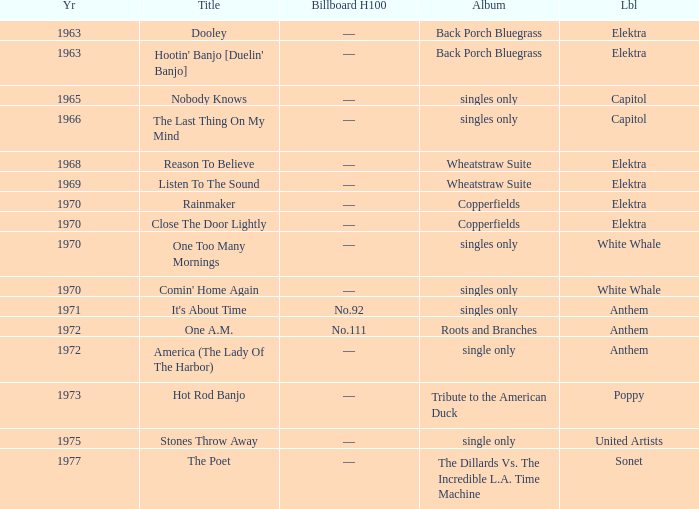What is the total years for roots and branches? 1972.0. 